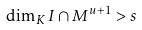<formula> <loc_0><loc_0><loc_500><loc_500>\dim _ { K } I \cap M ^ { u + 1 } > s</formula> 